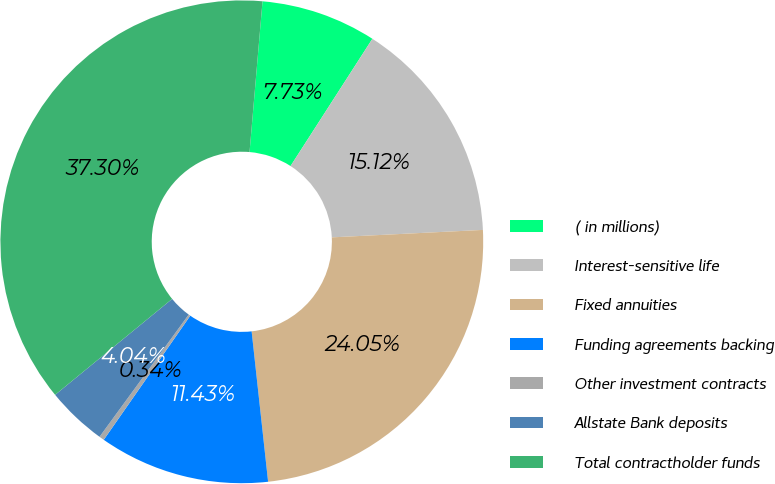Convert chart to OTSL. <chart><loc_0><loc_0><loc_500><loc_500><pie_chart><fcel>( in millions)<fcel>Interest-sensitive life<fcel>Fixed annuities<fcel>Funding agreements backing<fcel>Other investment contracts<fcel>Allstate Bank deposits<fcel>Total contractholder funds<nl><fcel>7.73%<fcel>15.12%<fcel>24.05%<fcel>11.43%<fcel>0.34%<fcel>4.04%<fcel>37.3%<nl></chart> 